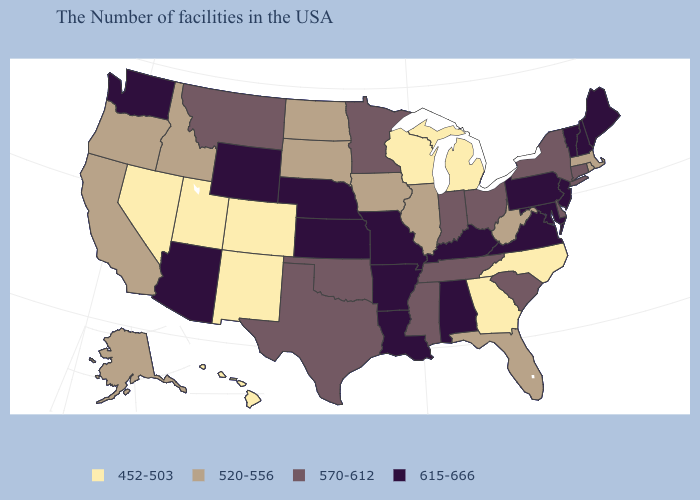Name the states that have a value in the range 452-503?
Keep it brief. North Carolina, Georgia, Michigan, Wisconsin, Colorado, New Mexico, Utah, Nevada, Hawaii. Which states hav the highest value in the Northeast?
Short answer required. Maine, New Hampshire, Vermont, New Jersey, Pennsylvania. What is the value of North Dakota?
Write a very short answer. 520-556. Does the map have missing data?
Quick response, please. No. Among the states that border Missouri , which have the lowest value?
Give a very brief answer. Illinois, Iowa. What is the lowest value in the West?
Concise answer only. 452-503. What is the value of Minnesota?
Answer briefly. 570-612. Does Georgia have the lowest value in the USA?
Be succinct. Yes. Which states hav the highest value in the South?
Short answer required. Maryland, Virginia, Kentucky, Alabama, Louisiana, Arkansas. Name the states that have a value in the range 570-612?
Quick response, please. Connecticut, New York, Delaware, South Carolina, Ohio, Indiana, Tennessee, Mississippi, Minnesota, Oklahoma, Texas, Montana. Name the states that have a value in the range 452-503?
Write a very short answer. North Carolina, Georgia, Michigan, Wisconsin, Colorado, New Mexico, Utah, Nevada, Hawaii. How many symbols are there in the legend?
Be succinct. 4. Does Kansas have a higher value than Oregon?
Answer briefly. Yes. Does the first symbol in the legend represent the smallest category?
Give a very brief answer. Yes. What is the lowest value in the USA?
Concise answer only. 452-503. 